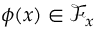Convert formula to latex. <formula><loc_0><loc_0><loc_500><loc_500>\phi ( x ) \in \mathcal { F } _ { x }</formula> 